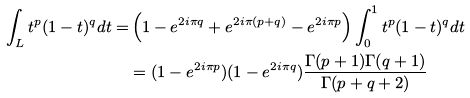<formula> <loc_0><loc_0><loc_500><loc_500>\int _ { L } t ^ { p } ( 1 - t ) ^ { q } d t = & \left ( 1 - e ^ { 2 i \pi q } + e ^ { 2 i \pi ( p + q ) } - e ^ { 2 i \pi p } \right ) \int _ { 0 } ^ { 1 } t ^ { p } ( 1 - t ) ^ { q } d t \\ & = ( 1 - e ^ { 2 i \pi p } ) ( 1 - e ^ { 2 i \pi q } ) \frac { \Gamma ( p + 1 ) \Gamma ( q + 1 ) } { \Gamma ( p + q + 2 ) }</formula> 